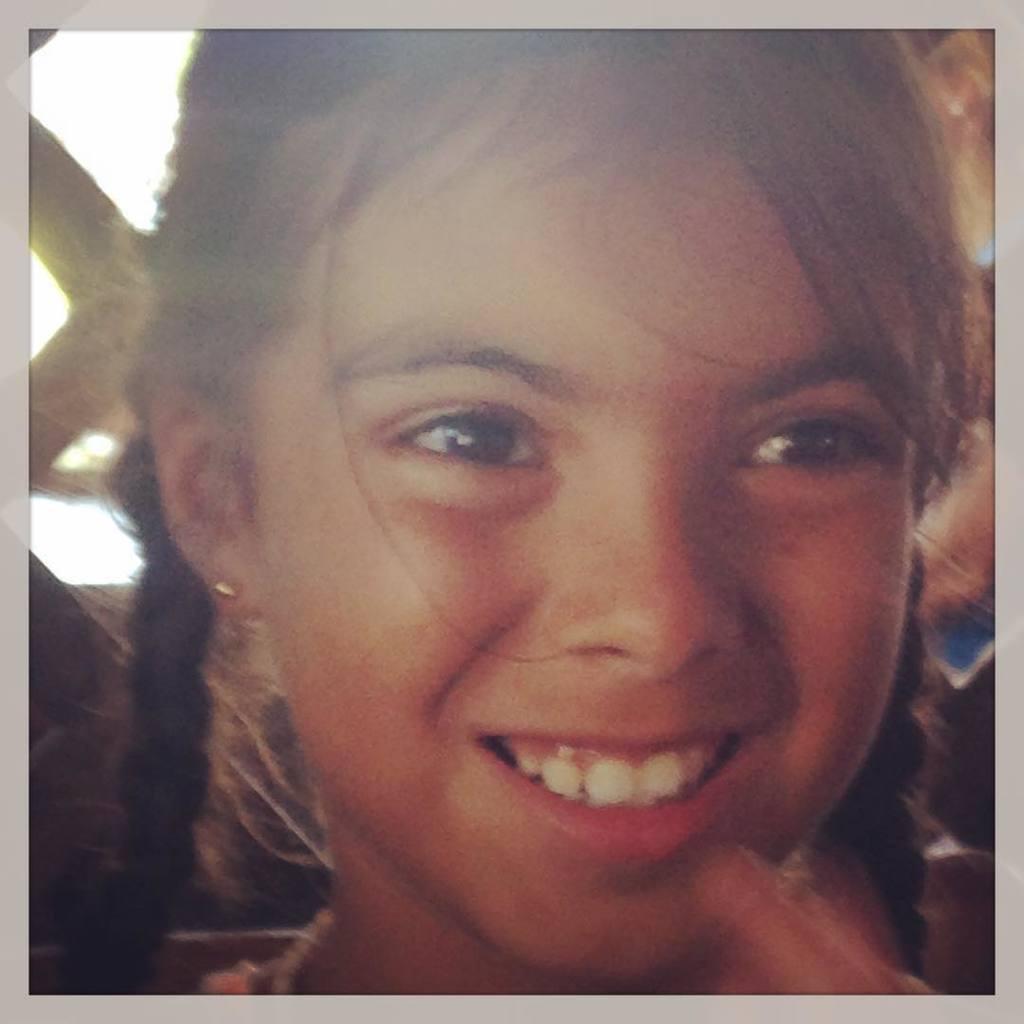How would you summarize this image in a sentence or two? In the picture I can see a girl is smiling. 